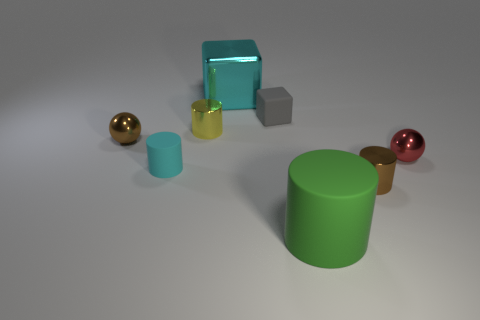Subtract 1 cylinders. How many cylinders are left? 3 Add 1 brown balls. How many objects exist? 9 Subtract all red cylinders. Subtract all brown spheres. How many cylinders are left? 4 Subtract all balls. How many objects are left? 6 Subtract 0 green cubes. How many objects are left? 8 Subtract all tiny cyan objects. Subtract all big matte objects. How many objects are left? 6 Add 1 tiny gray cubes. How many tiny gray cubes are left? 2 Add 3 balls. How many balls exist? 5 